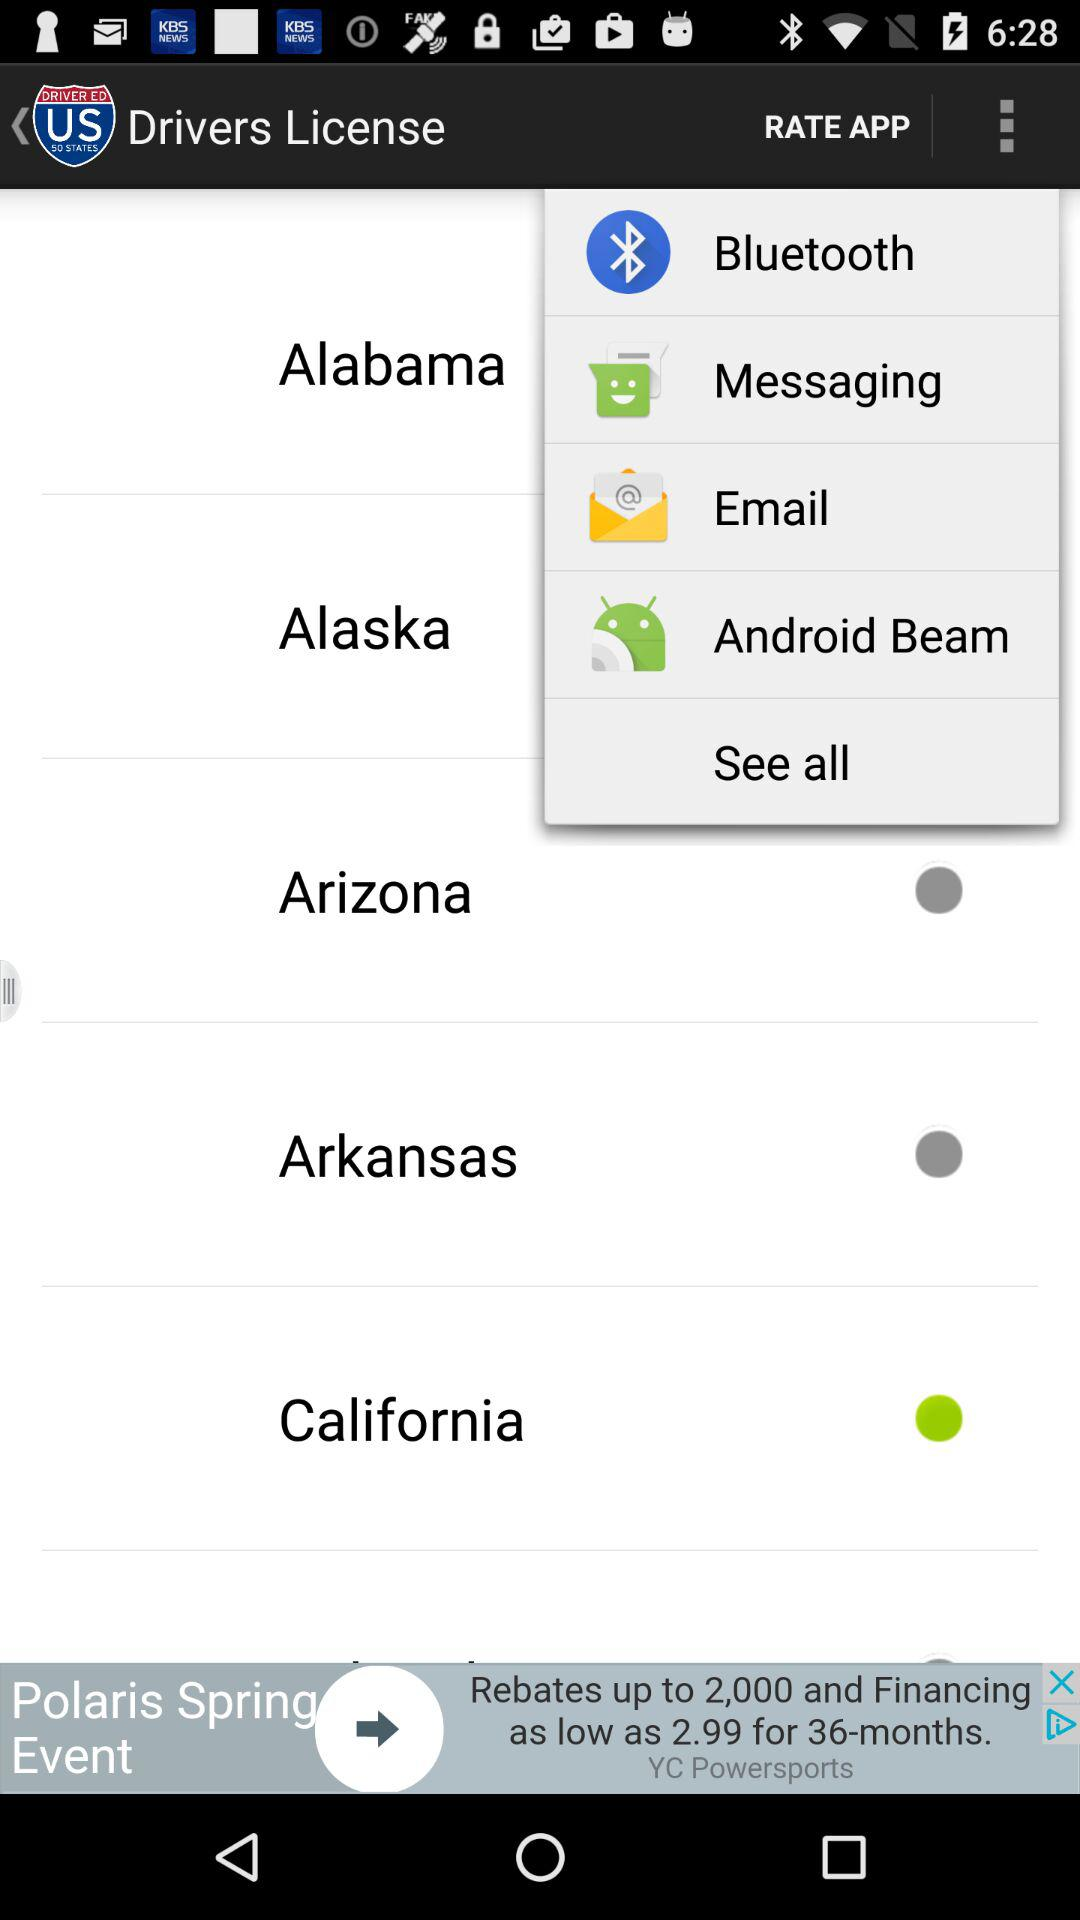Which is the selected city? The selected city is California. 